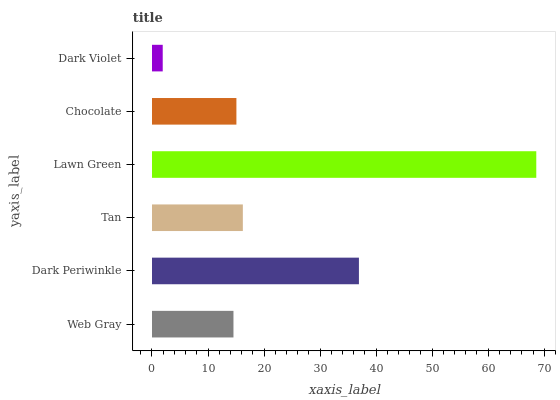Is Dark Violet the minimum?
Answer yes or no. Yes. Is Lawn Green the maximum?
Answer yes or no. Yes. Is Dark Periwinkle the minimum?
Answer yes or no. No. Is Dark Periwinkle the maximum?
Answer yes or no. No. Is Dark Periwinkle greater than Web Gray?
Answer yes or no. Yes. Is Web Gray less than Dark Periwinkle?
Answer yes or no. Yes. Is Web Gray greater than Dark Periwinkle?
Answer yes or no. No. Is Dark Periwinkle less than Web Gray?
Answer yes or no. No. Is Tan the high median?
Answer yes or no. Yes. Is Chocolate the low median?
Answer yes or no. Yes. Is Chocolate the high median?
Answer yes or no. No. Is Dark Periwinkle the low median?
Answer yes or no. No. 